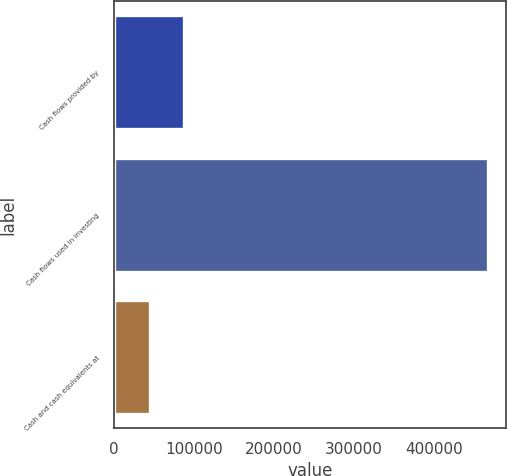Convert chart. <chart><loc_0><loc_0><loc_500><loc_500><bar_chart><fcel>Cash flows provided by<fcel>Cash flows used in investing<fcel>Cash and cash equivalents at<nl><fcel>87503.5<fcel>466714<fcel>45369<nl></chart> 